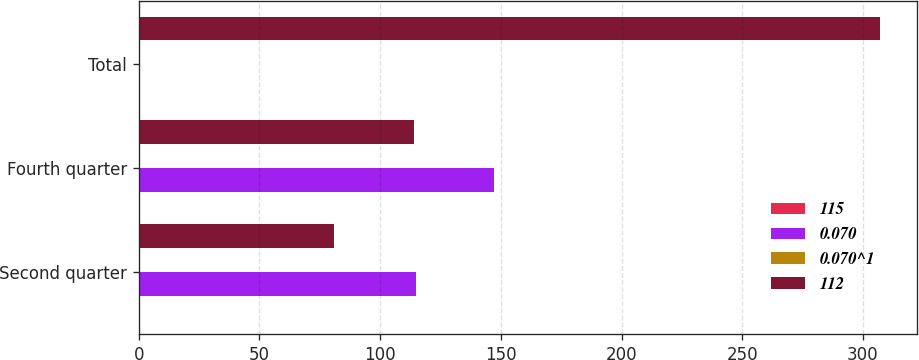Convert chart to OTSL. <chart><loc_0><loc_0><loc_500><loc_500><stacked_bar_chart><ecel><fcel>Second quarter<fcel>Fourth quarter<fcel>Total<nl><fcel>115<fcel>0.07<fcel>0.09<fcel>0.32<nl><fcel>0.070<fcel>115<fcel>147<fcel>0.32<nl><fcel>0.070^1<fcel>0.05<fcel>0.07<fcel>0.19<nl><fcel>112<fcel>81<fcel>114<fcel>307<nl></chart> 